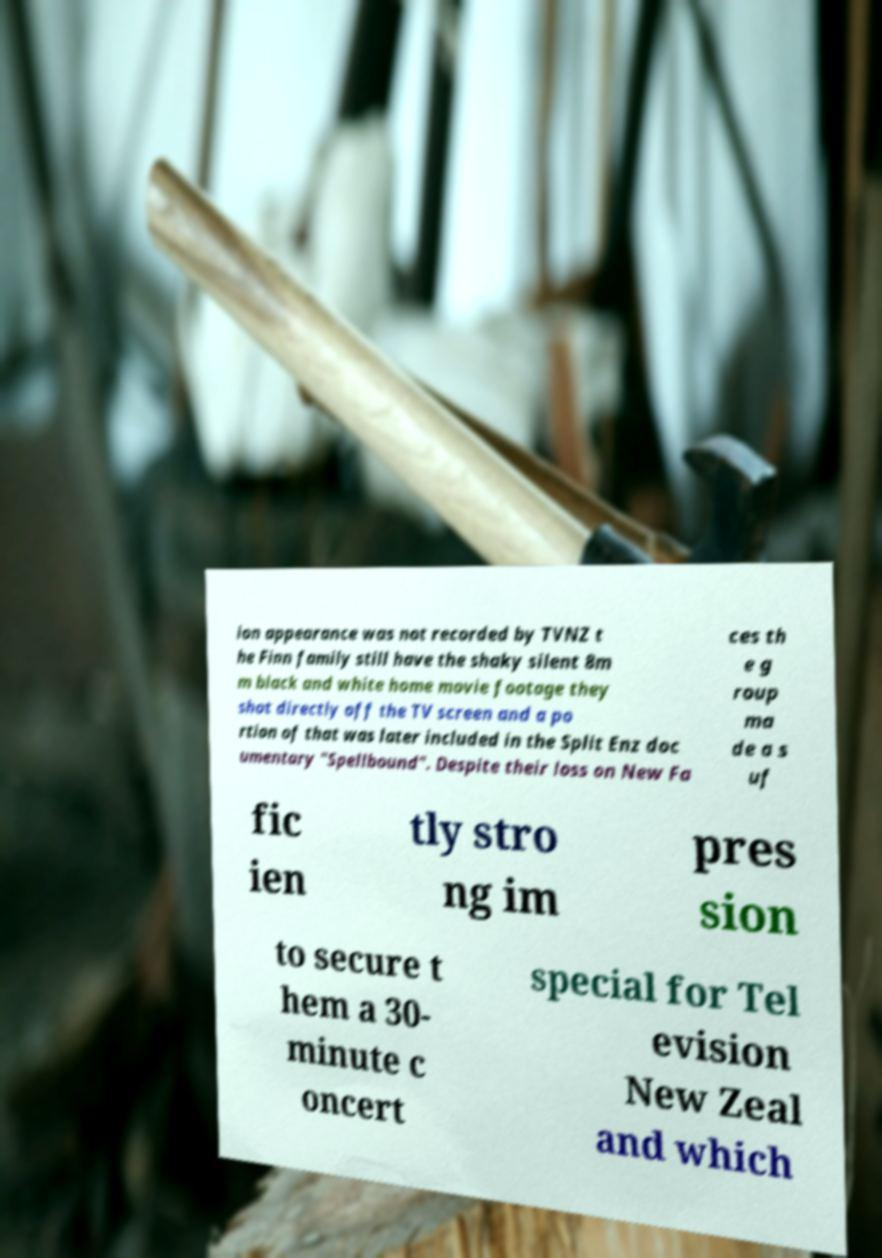Please read and relay the text visible in this image. What does it say? ion appearance was not recorded by TVNZ t he Finn family still have the shaky silent 8m m black and white home movie footage they shot directly off the TV screen and a po rtion of that was later included in the Split Enz doc umentary "Spellbound". Despite their loss on New Fa ces th e g roup ma de a s uf fic ien tly stro ng im pres sion to secure t hem a 30- minute c oncert special for Tel evision New Zeal and which 